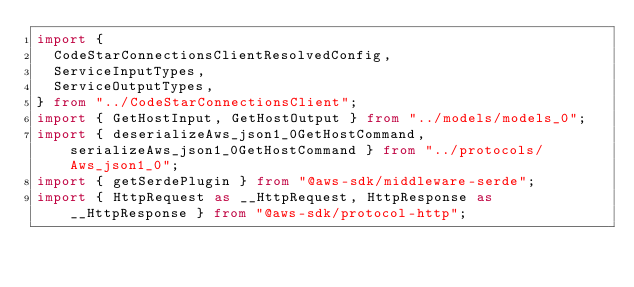Convert code to text. <code><loc_0><loc_0><loc_500><loc_500><_TypeScript_>import {
  CodeStarConnectionsClientResolvedConfig,
  ServiceInputTypes,
  ServiceOutputTypes,
} from "../CodeStarConnectionsClient";
import { GetHostInput, GetHostOutput } from "../models/models_0";
import { deserializeAws_json1_0GetHostCommand, serializeAws_json1_0GetHostCommand } from "../protocols/Aws_json1_0";
import { getSerdePlugin } from "@aws-sdk/middleware-serde";
import { HttpRequest as __HttpRequest, HttpResponse as __HttpResponse } from "@aws-sdk/protocol-http";</code> 